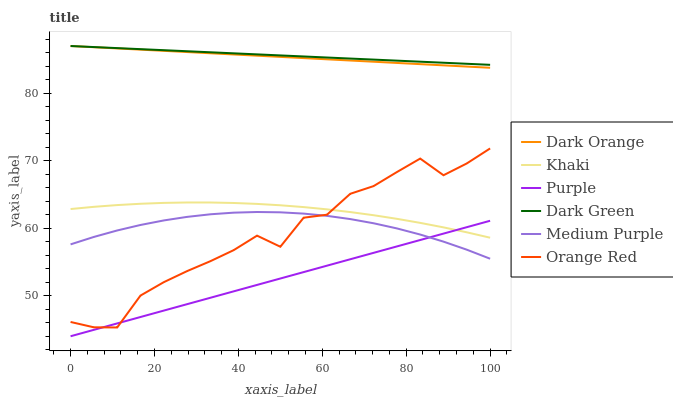Does Purple have the minimum area under the curve?
Answer yes or no. Yes. Does Dark Green have the maximum area under the curve?
Answer yes or no. Yes. Does Khaki have the minimum area under the curve?
Answer yes or no. No. Does Khaki have the maximum area under the curve?
Answer yes or no. No. Is Purple the smoothest?
Answer yes or no. Yes. Is Orange Red the roughest?
Answer yes or no. Yes. Is Khaki the smoothest?
Answer yes or no. No. Is Khaki the roughest?
Answer yes or no. No. Does Purple have the lowest value?
Answer yes or no. Yes. Does Khaki have the lowest value?
Answer yes or no. No. Does Dark Green have the highest value?
Answer yes or no. Yes. Does Khaki have the highest value?
Answer yes or no. No. Is Medium Purple less than Dark Orange?
Answer yes or no. Yes. Is Dark Green greater than Purple?
Answer yes or no. Yes. Does Khaki intersect Orange Red?
Answer yes or no. Yes. Is Khaki less than Orange Red?
Answer yes or no. No. Is Khaki greater than Orange Red?
Answer yes or no. No. Does Medium Purple intersect Dark Orange?
Answer yes or no. No. 